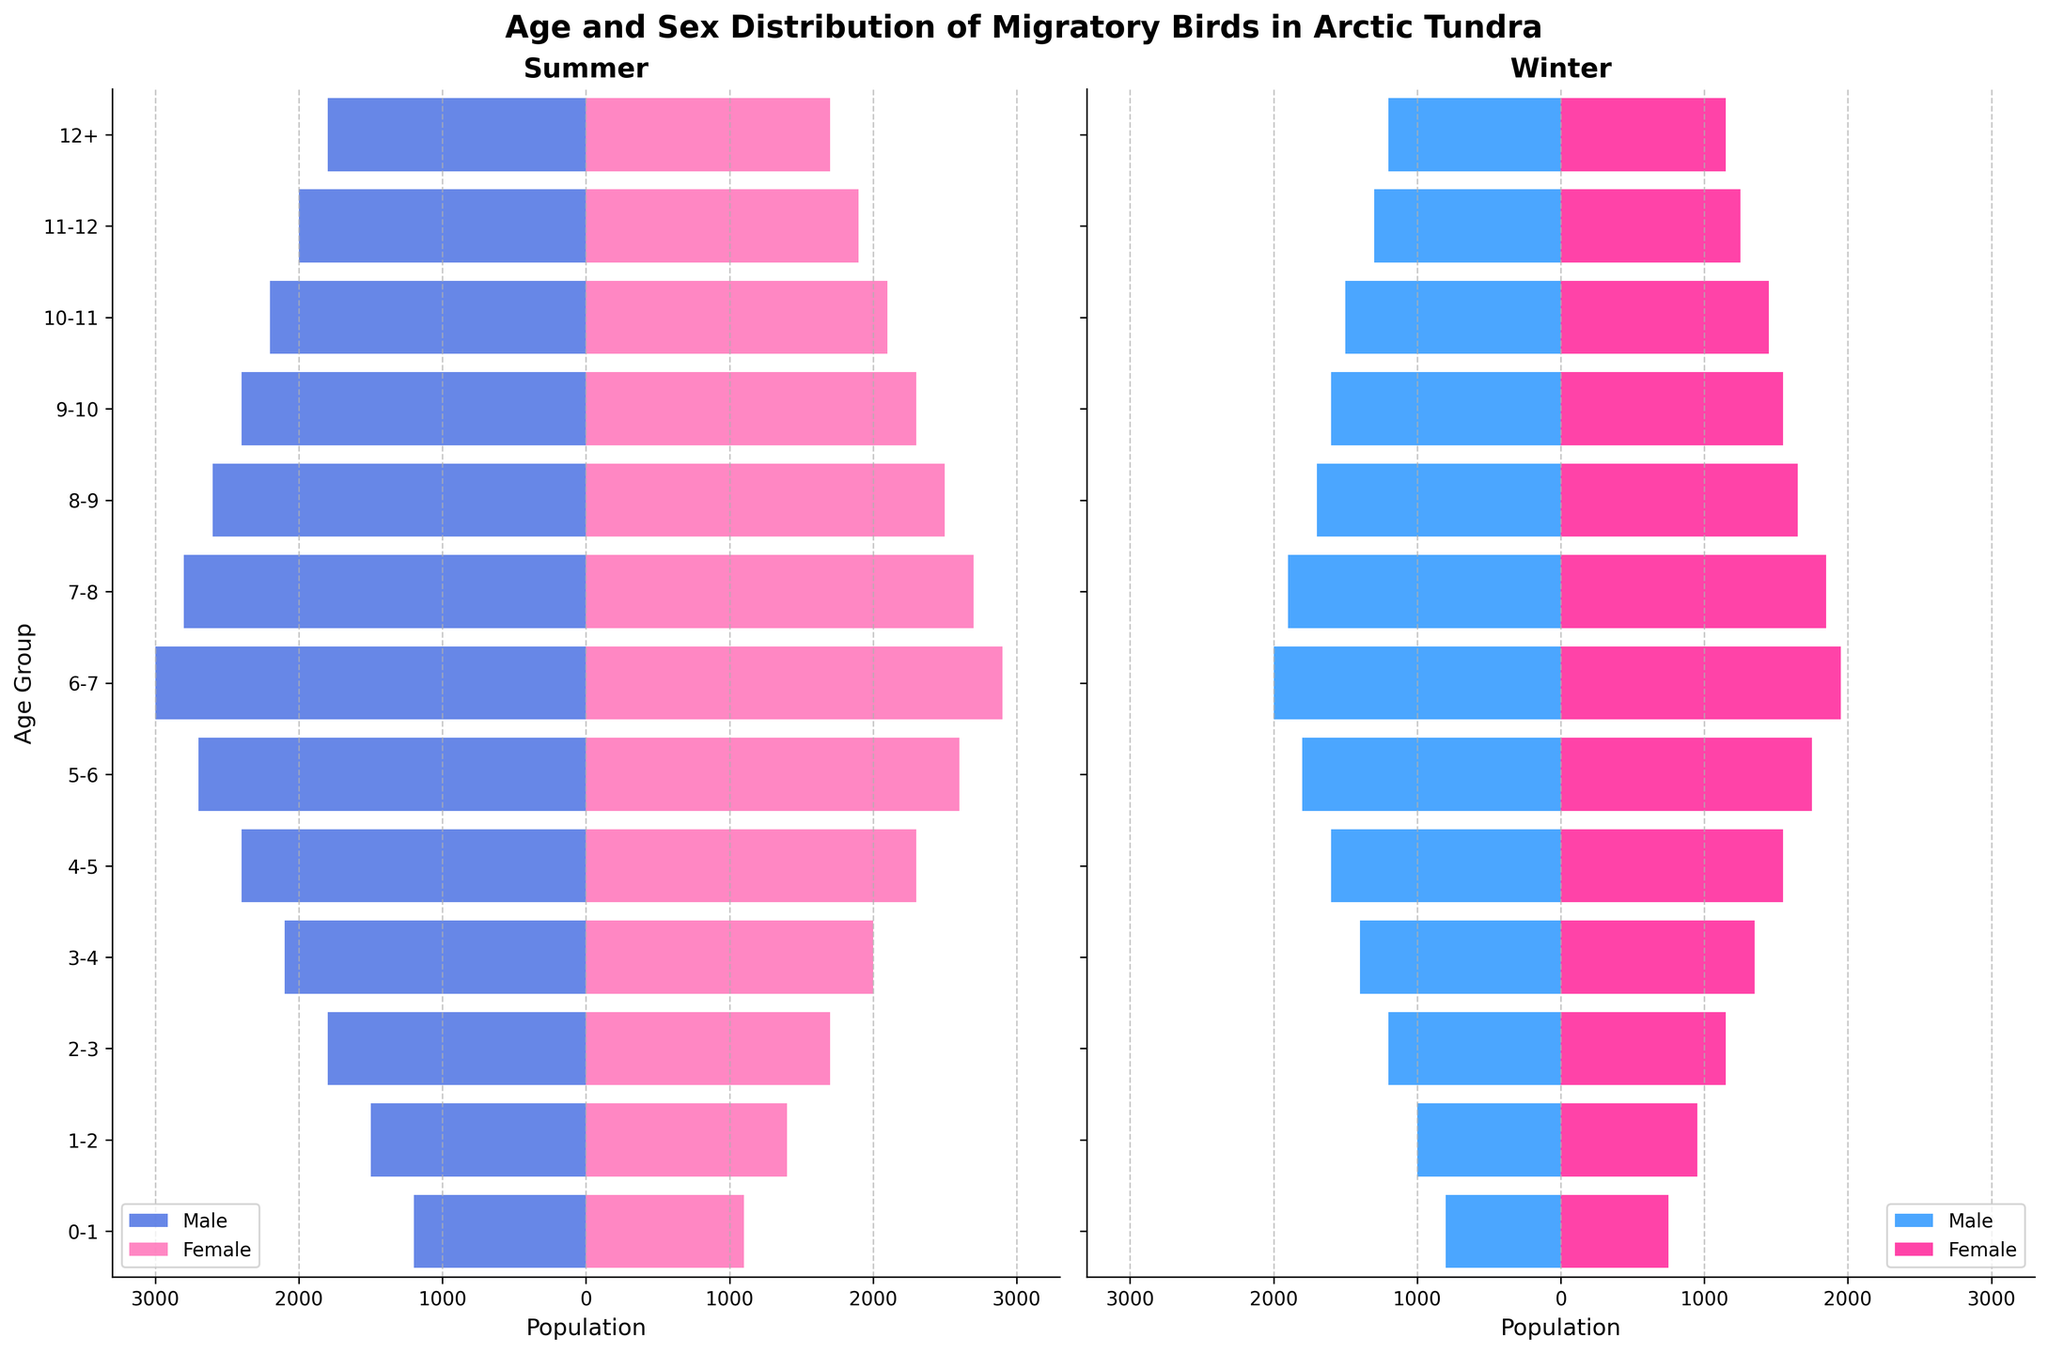How many age groups are displayed in the figure? The figure displays a bar for each age group. Count the number of distinct age group labels on the vertical axis.
Answer: 13 What is the population of male birds in the 3-4 age group during winter? Identify the "3-4" age group from the vertical axis on the winter side and look at the length of the bar representing male birds in this category. The negative value indicates the male population.
Answer: 1400 Which season has a higher population of female birds in the 0-1 age group? Compare the lengths of the female bars for the 0-1 age group in both summer and winter panels. The longer bar indicates a larger population.
Answer: Summer What is the total population of 6-7 age group birds during summer? Add the populations of both male and female birds for the 6-7 age group in the summer panel.
Answer: 5900 What is the difference in the population of male birds between the 7-8 and 8-9 age groups during summer? Identify the male populations for each age group from the summer panel and subtract the population of the 8-9 age group from the 7-8 age group.
Answer: 200 Across all age groups, do males or females have the higher maximum population in winter? Identify the highest female and male population values in the winter panel by looking at the bars and compare these values directly.
Answer: Male Which age group shows the largest decrease in male population from summer to winter? For each age group, calculate the difference between the male populations in summer and winter. The largest numerical decrease will indicate the largest reduction.
Answer: 0-1 In which season is the age group 5-6 closer in population counts between males and females? Compare the lengths of the bars for male and female birds within the 5-6 age group in both summer and winter. Calculate the absolute difference for each season, and the smaller difference will indicate the closer counts.
Answer: Winter 